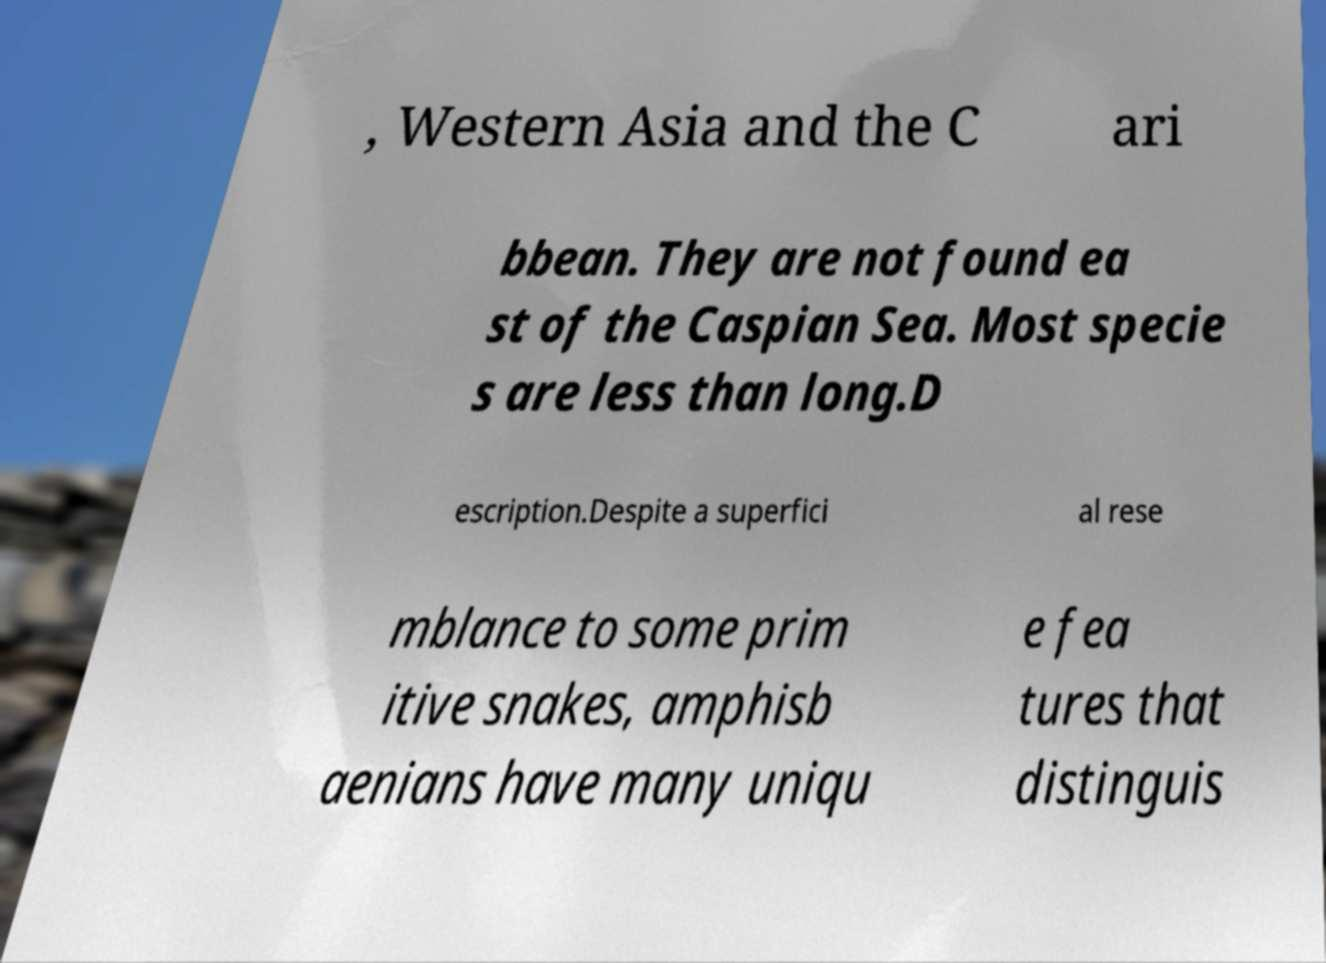Could you extract and type out the text from this image? , Western Asia and the C ari bbean. They are not found ea st of the Caspian Sea. Most specie s are less than long.D escription.Despite a superfici al rese mblance to some prim itive snakes, amphisb aenians have many uniqu e fea tures that distinguis 